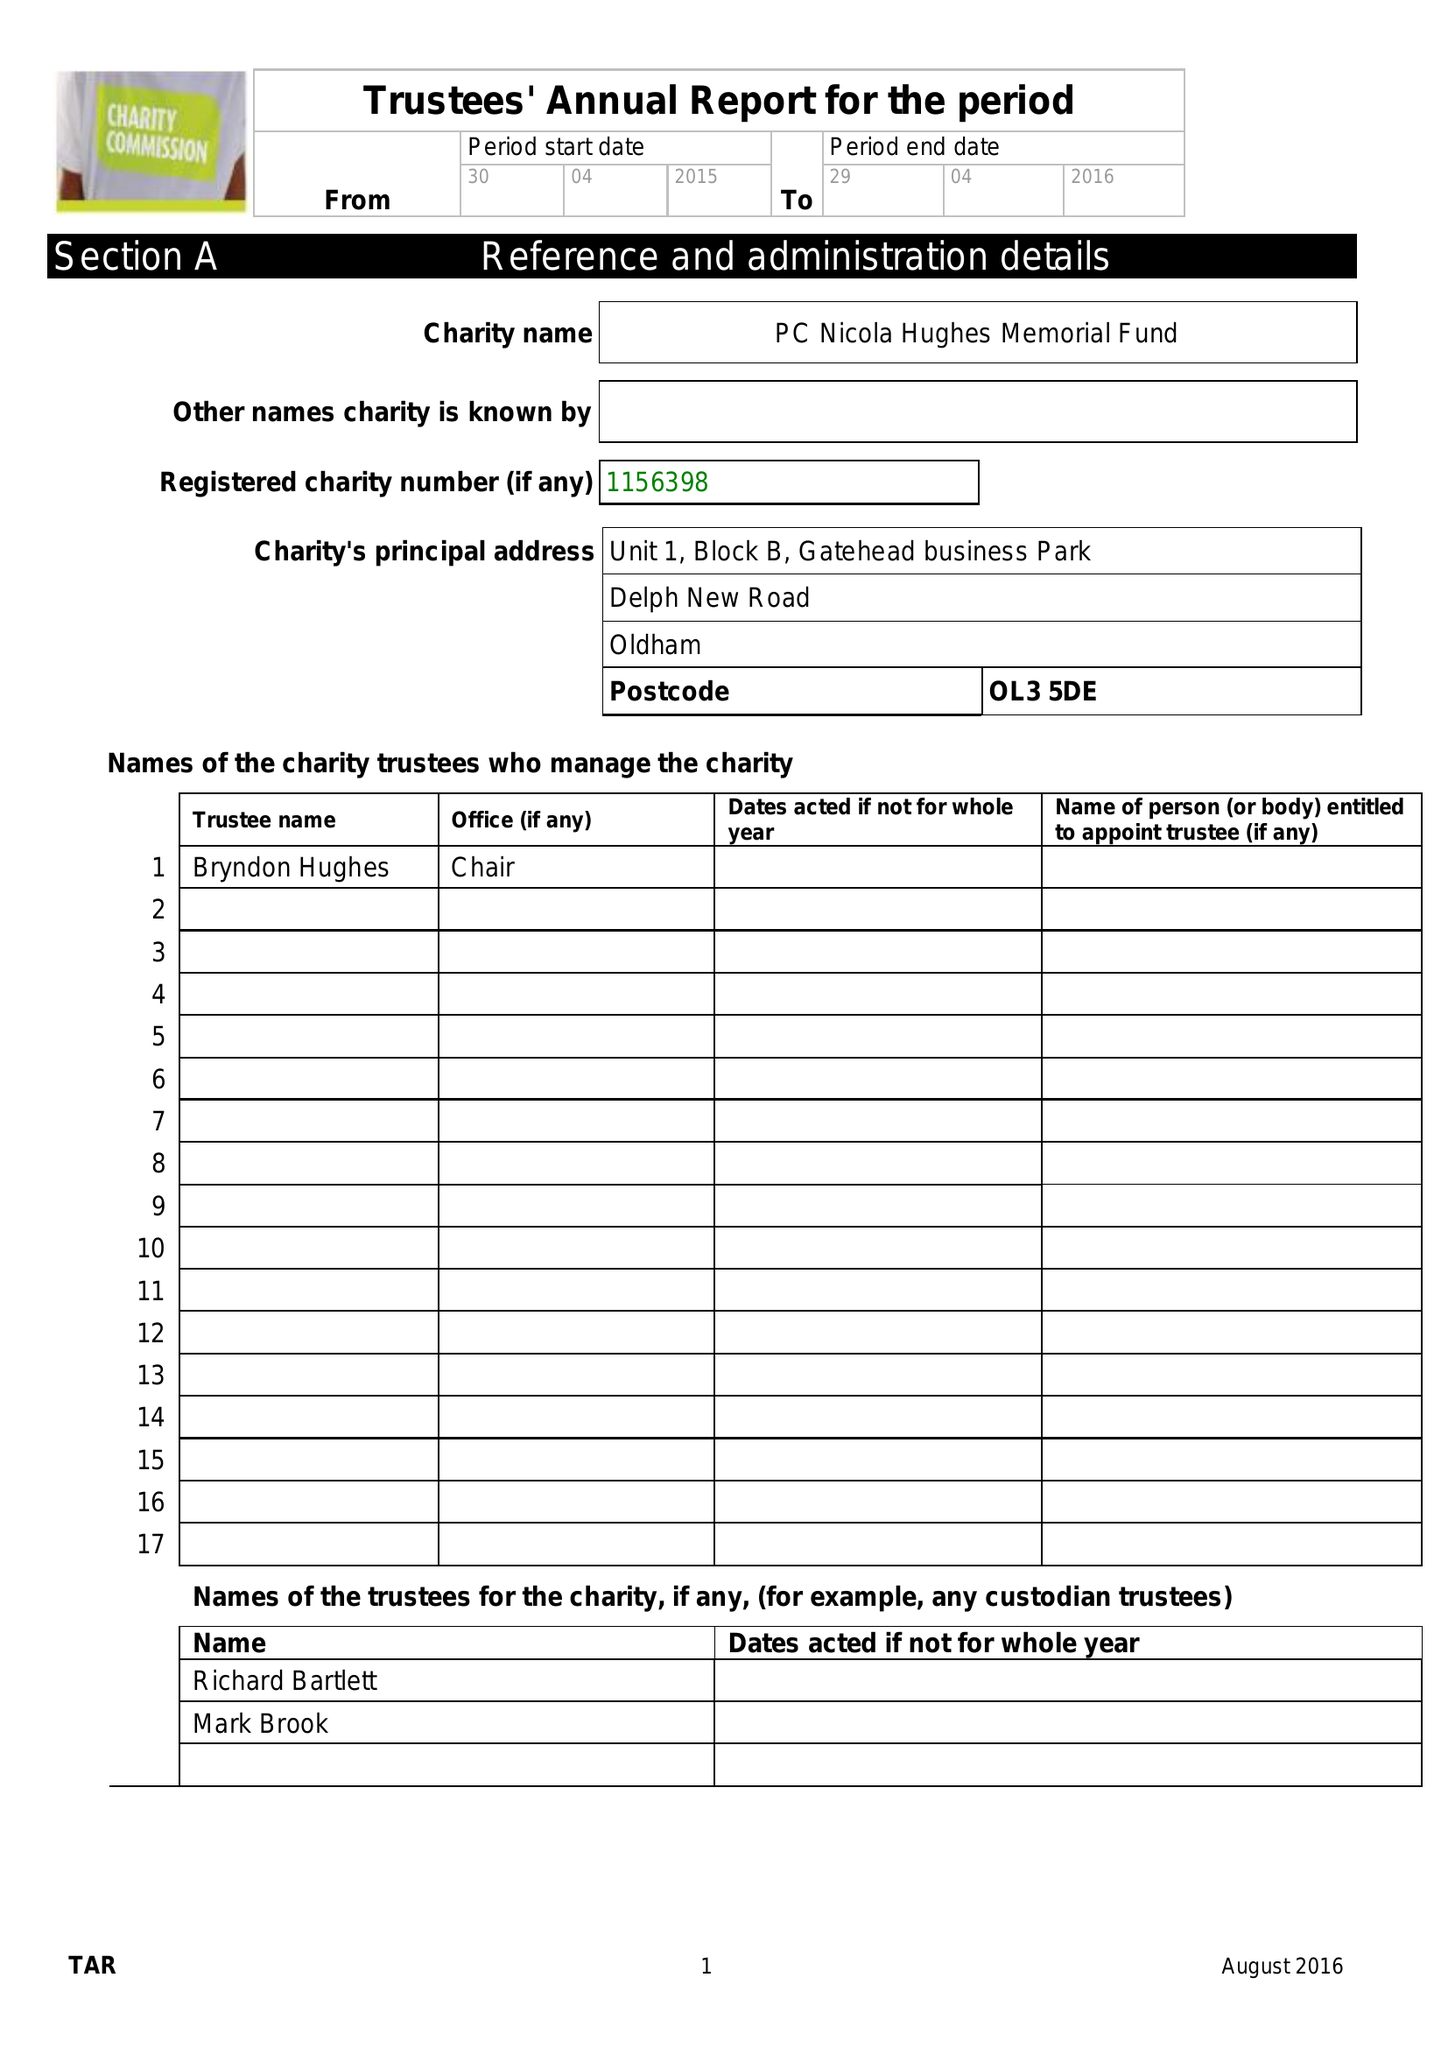What is the value for the income_annually_in_british_pounds?
Answer the question using a single word or phrase. 103373.00 